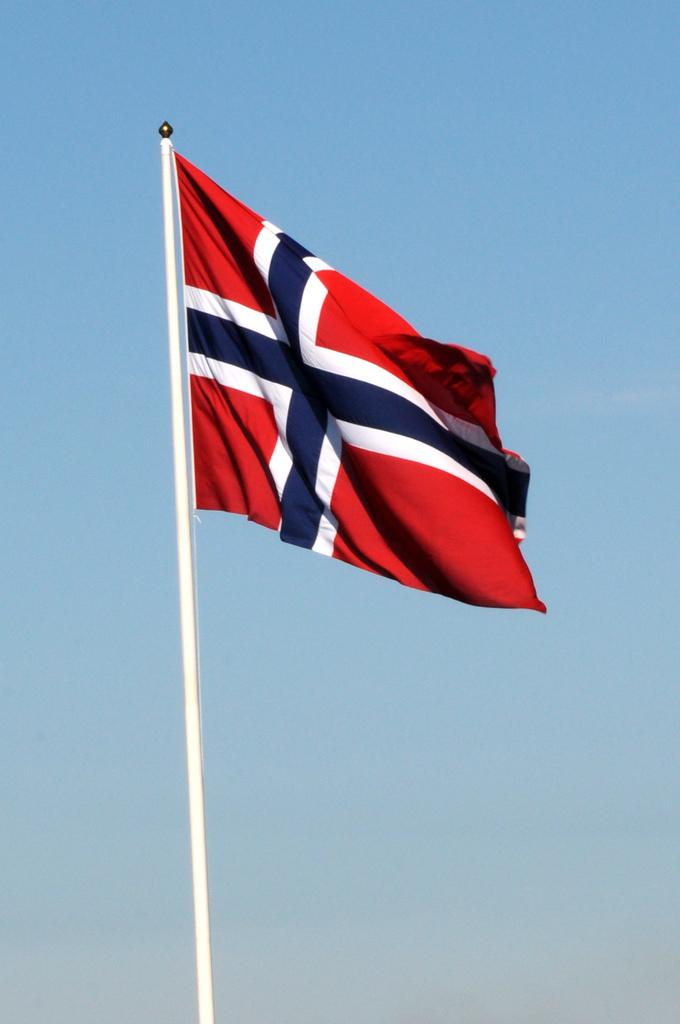What is the main object in the image? There is a pole in the image. What is attached to the pole? A flag is present on the pole. What colors are featured on the flag? The flag has white, red, and blue colors. What can be seen in the background of the image? The sky is visible in the background of the image. What is the condition of the sky in the image? The sky is clear in the image. What type of throne is depicted in the image? There is no throne present in the image; it features a pole with a flag. What team does the flag represent in the image? The image does not provide information about the flag representing a specific team. 